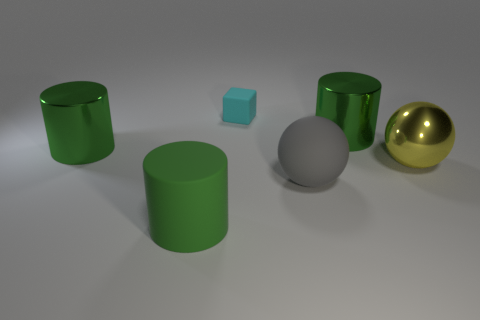Add 4 small matte cubes. How many objects exist? 10 Subtract all blocks. How many objects are left? 5 Subtract all tiny green objects. Subtract all cylinders. How many objects are left? 3 Add 4 spheres. How many spheres are left? 6 Add 1 cyan balls. How many cyan balls exist? 1 Subtract 0 brown cylinders. How many objects are left? 6 